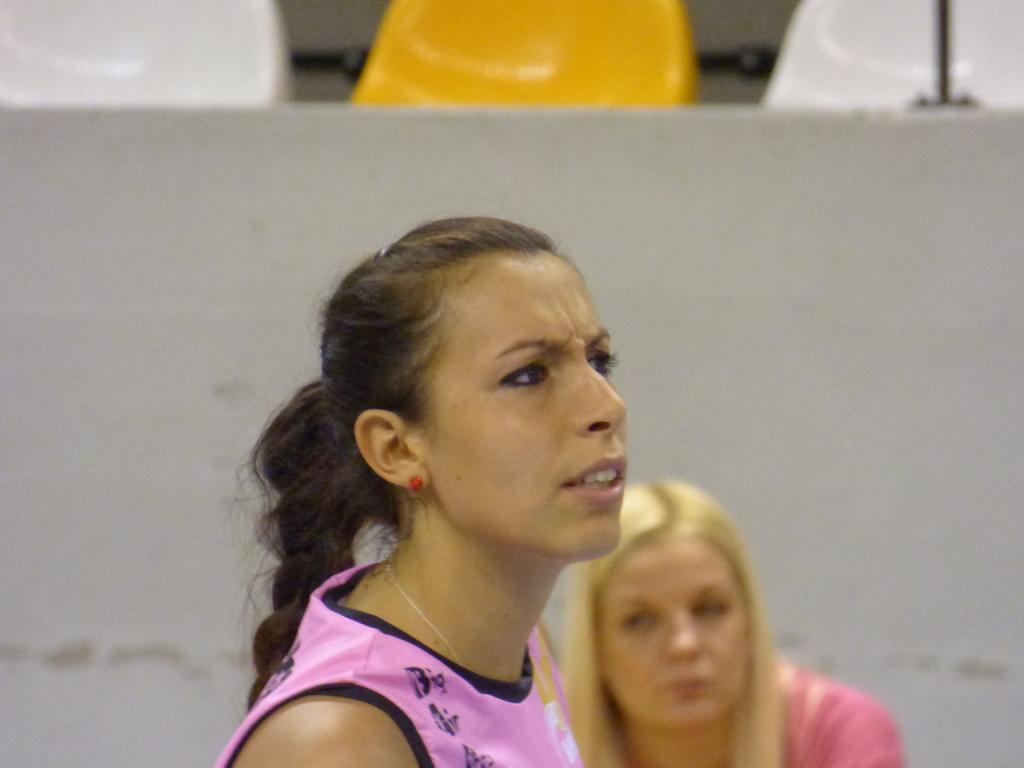Could you give a brief overview of what you see in this image? This image is taken outdoors. In the background there are a few empty chairs and there is a wall. At the bottom of the image there are two women. 